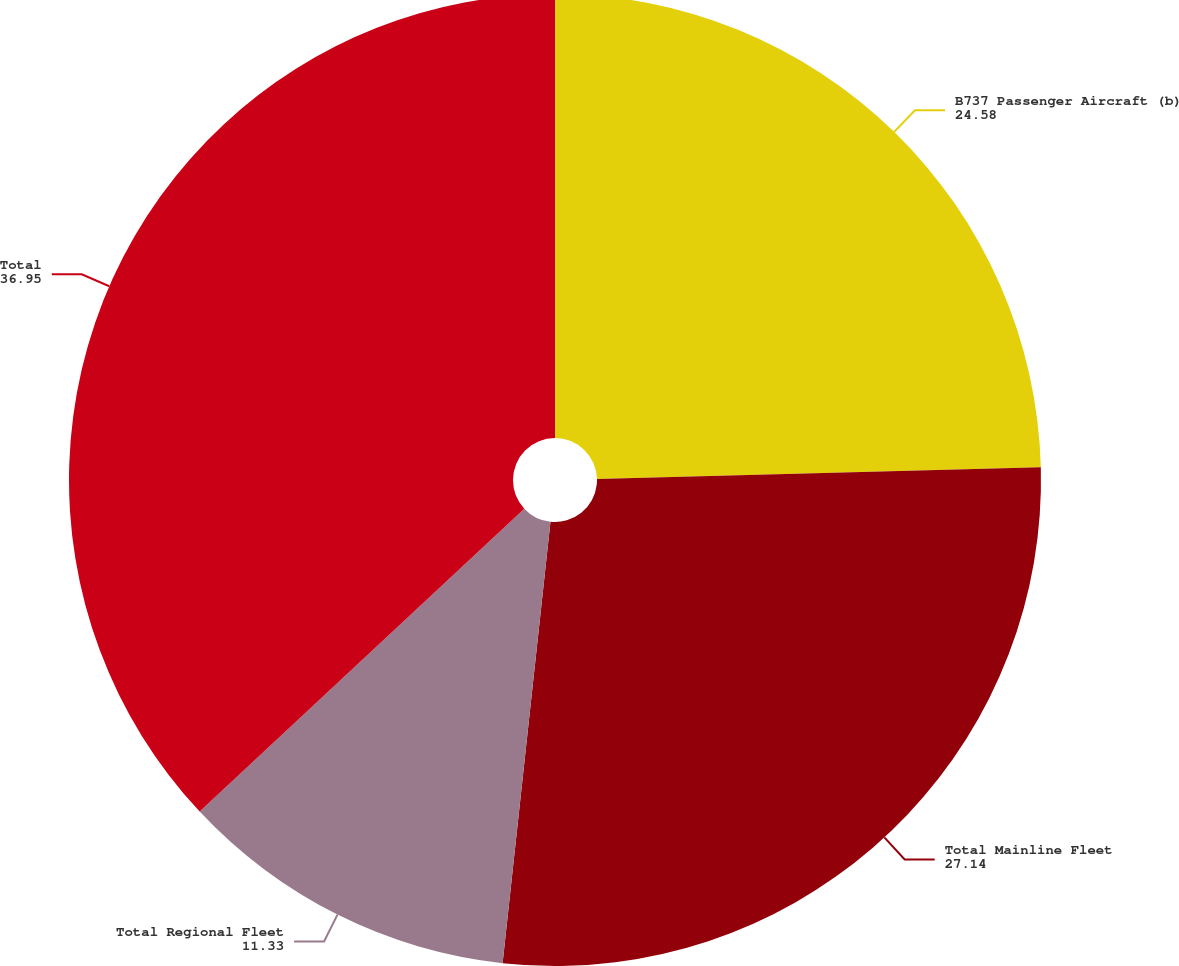Convert chart. <chart><loc_0><loc_0><loc_500><loc_500><pie_chart><fcel>B737 Passenger Aircraft (b)<fcel>Total Mainline Fleet<fcel>Total Regional Fleet<fcel>Total<nl><fcel>24.58%<fcel>27.14%<fcel>11.33%<fcel>36.95%<nl></chart> 